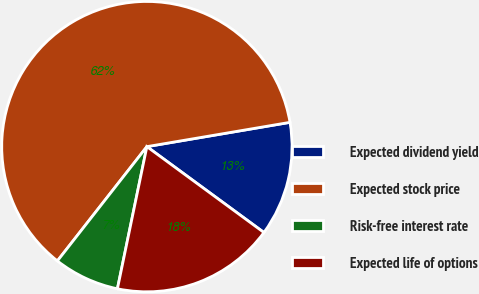<chart> <loc_0><loc_0><loc_500><loc_500><pie_chart><fcel>Expected dividend yield<fcel>Expected stock price<fcel>Risk-free interest rate<fcel>Expected life of options<nl><fcel>12.75%<fcel>61.75%<fcel>7.32%<fcel>18.18%<nl></chart> 